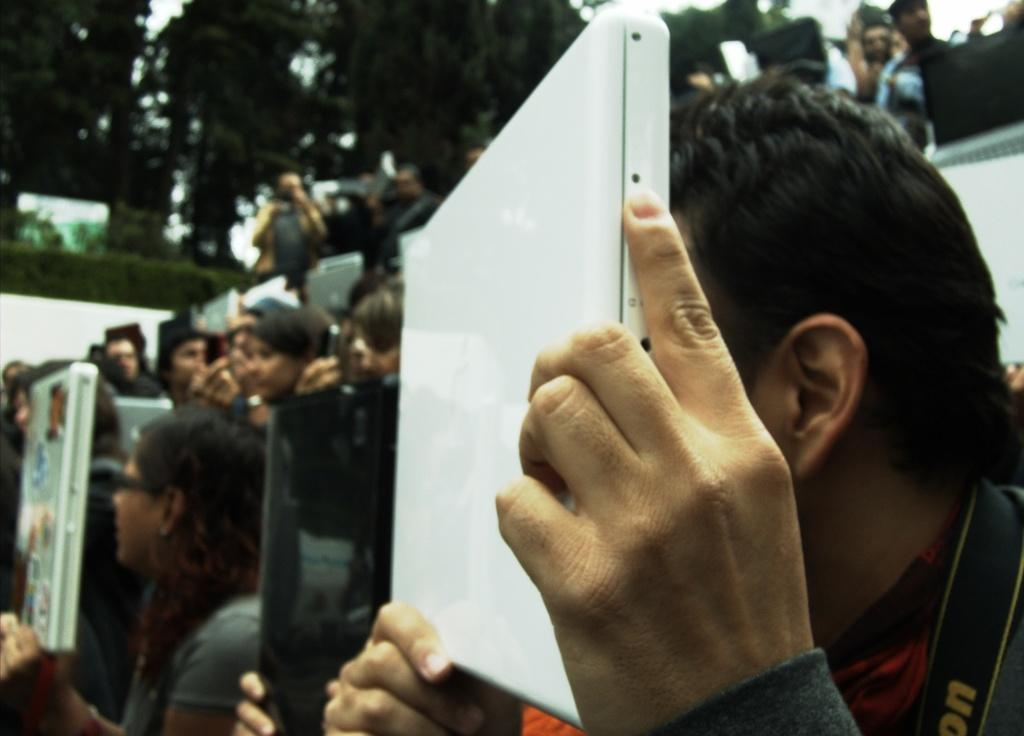What is happening in the foreground of the image? There are people in the foreground of the image. What are the people holding in their hands? The people are holding objects in their hands. What can be seen in the background of the image? There are trees and the sky visible in the background of the image. What type of knife is being used by the person in the image? There is no knife present in the image. How does the journey of the people in the image affect their stomachs? There is no journey or indication of stomach issues in the image. 